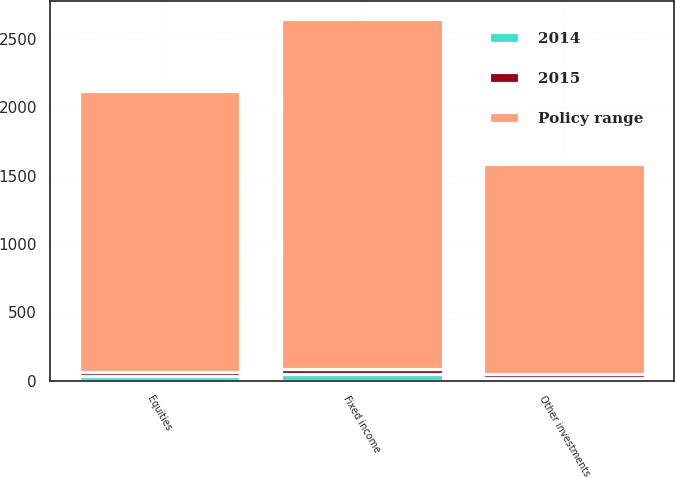Convert chart. <chart><loc_0><loc_0><loc_500><loc_500><stacked_bar_chart><ecel><fcel>Equities<fcel>Fixed income<fcel>Other investments<nl><fcel>Policy range<fcel>2055<fcel>2555<fcel>1535<nl><fcel>2015<fcel>30<fcel>43<fcel>27<nl><fcel>2014<fcel>33<fcel>45<fcel>22<nl></chart> 